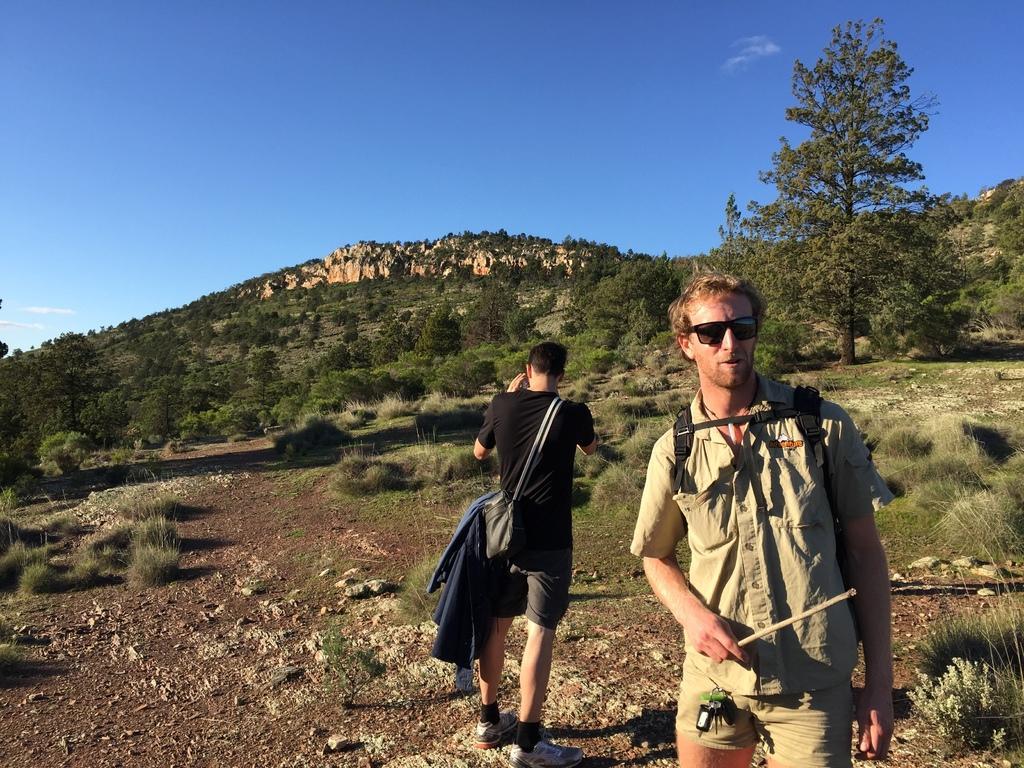Describe this image in one or two sentences. In this image there are two persons. In the background there is a mountain covered with grass and plants. The sky is blue and to the right there is a tree. The man in the front is wearing a black bag and wearing shades. The man who is behind is wearing a side bag and a black t-shirt. 